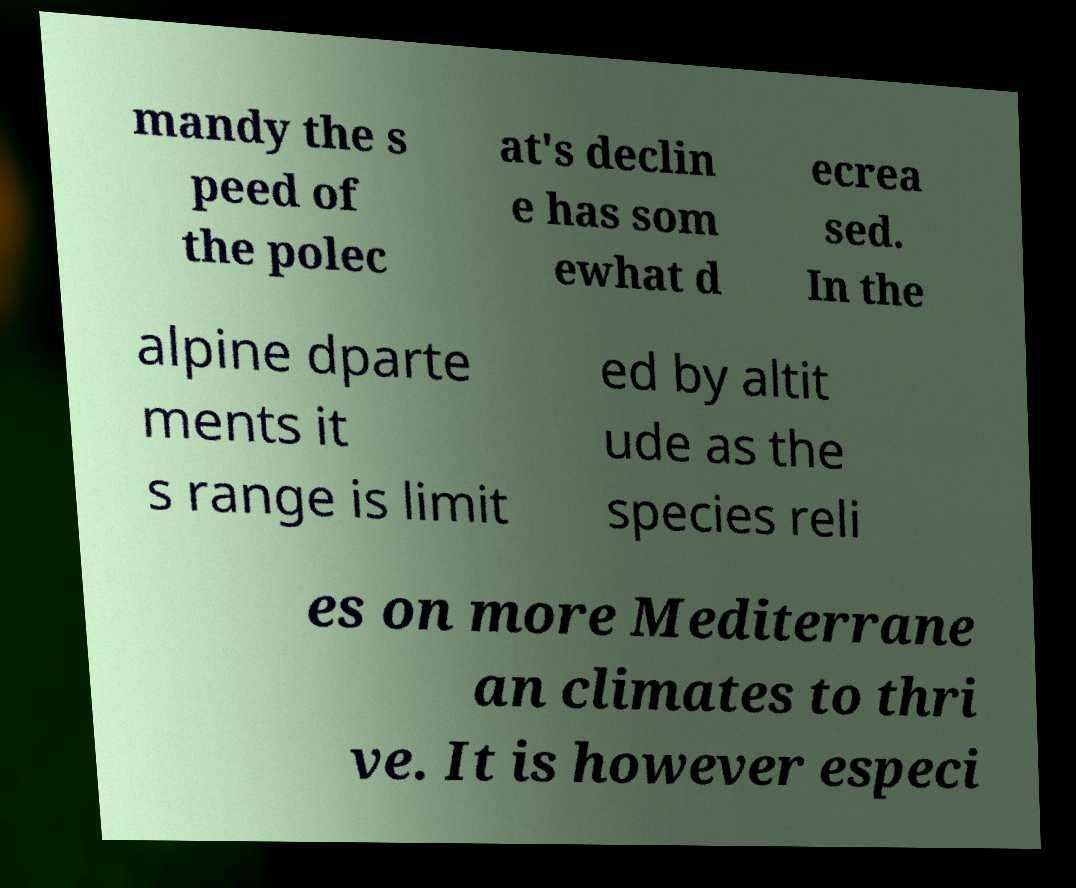Please read and relay the text visible in this image. What does it say? mandy the s peed of the polec at's declin e has som ewhat d ecrea sed. In the alpine dparte ments it s range is limit ed by altit ude as the species reli es on more Mediterrane an climates to thri ve. It is however especi 